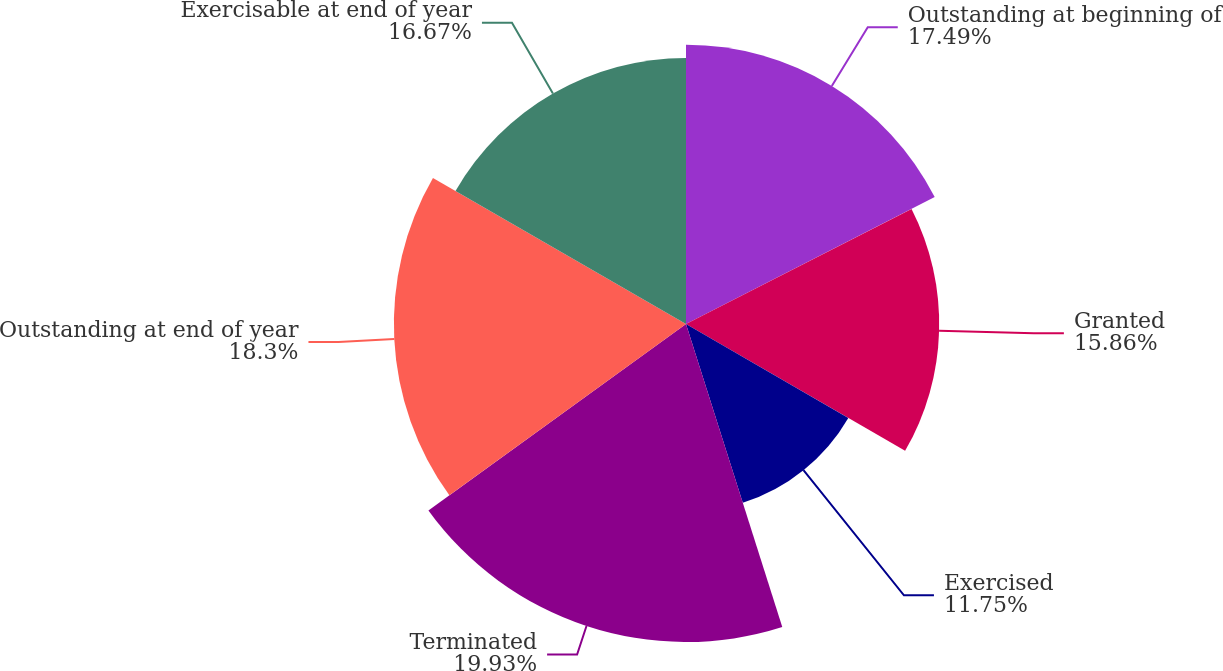<chart> <loc_0><loc_0><loc_500><loc_500><pie_chart><fcel>Outstanding at beginning of<fcel>Granted<fcel>Exercised<fcel>Terminated<fcel>Outstanding at end of year<fcel>Exercisable at end of year<nl><fcel>17.49%<fcel>15.86%<fcel>11.75%<fcel>19.92%<fcel>18.3%<fcel>16.67%<nl></chart> 